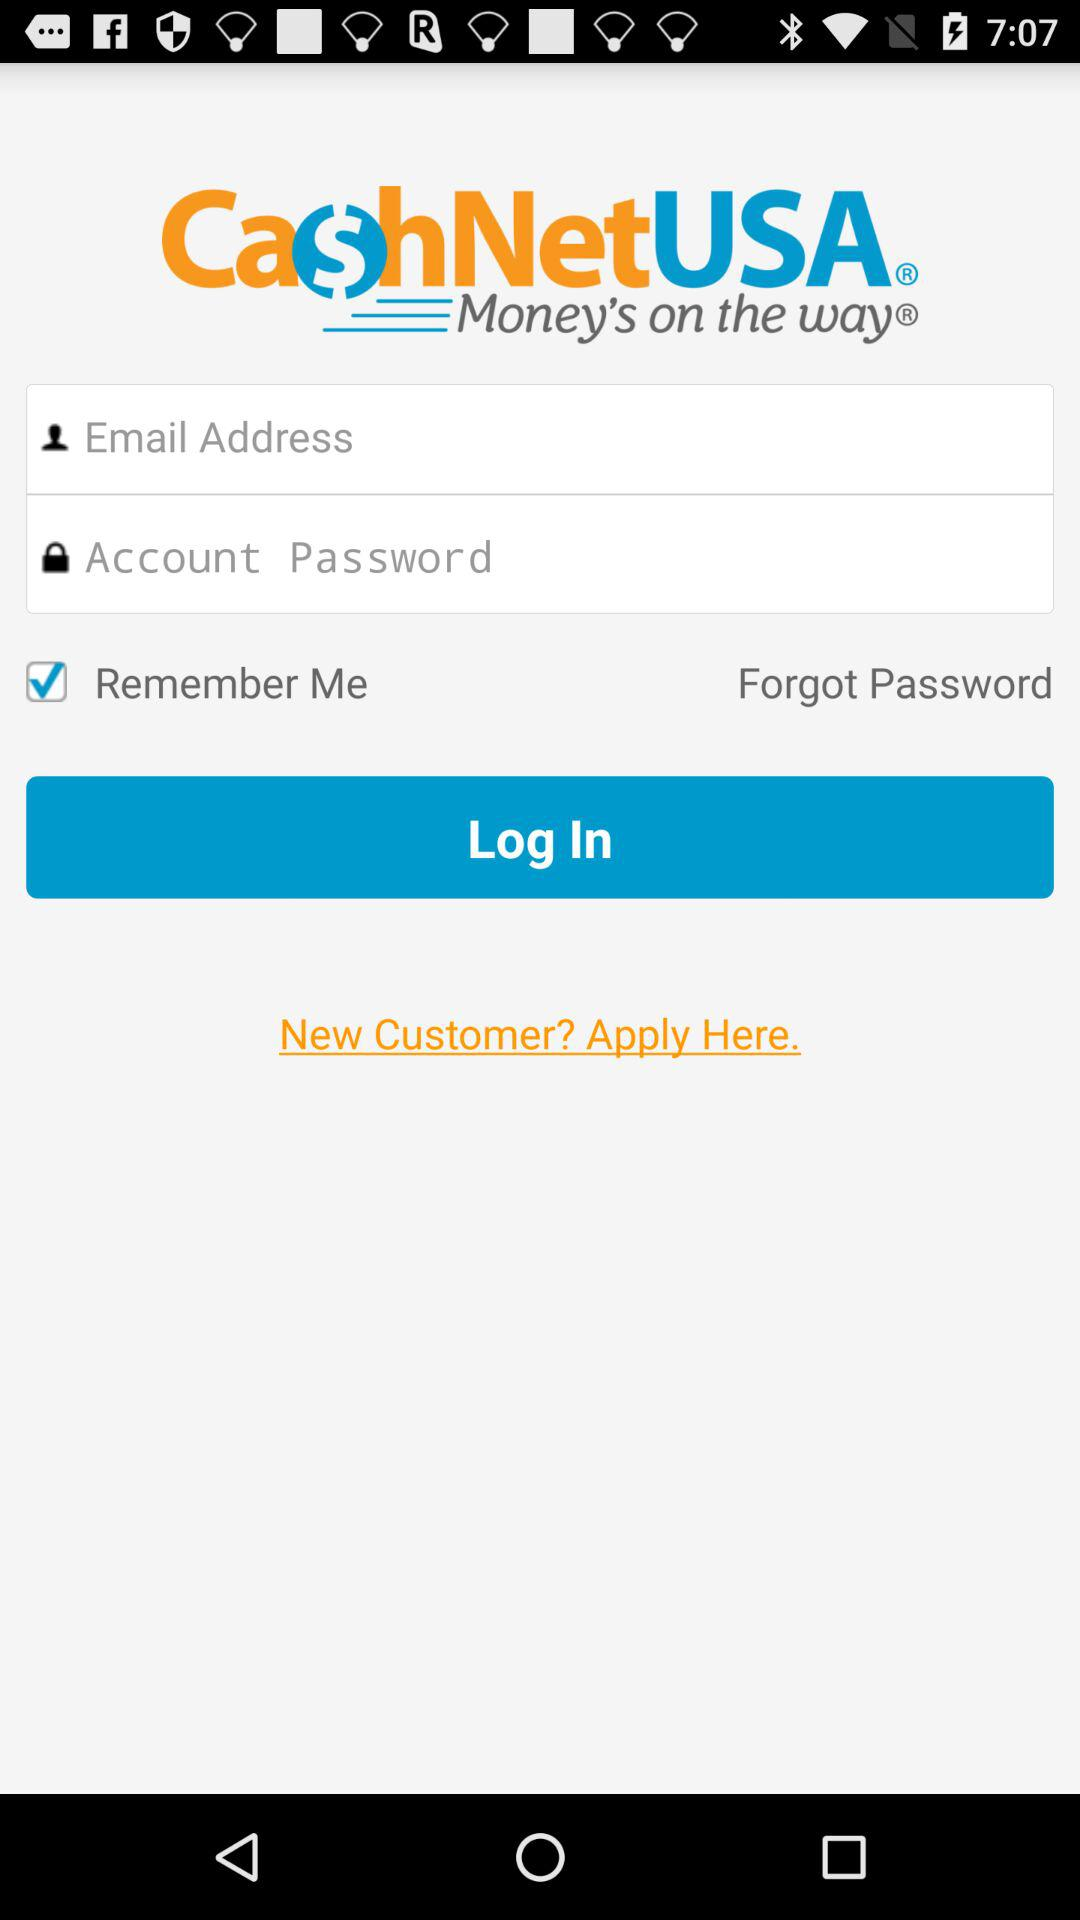What is the name of the application? The name of the application is "CashNetUSA". 